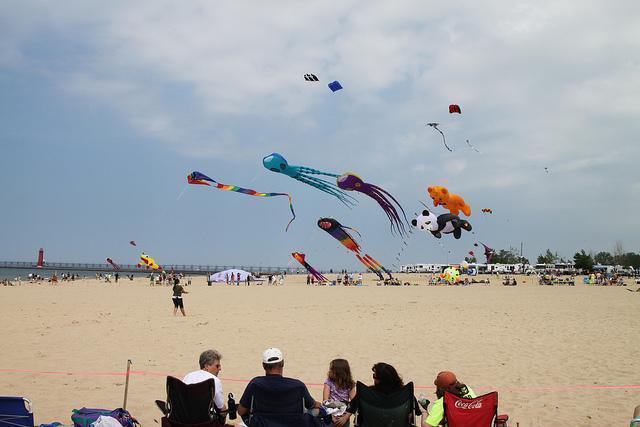How many yellow kites are in the air?
Give a very brief answer. 1. How many people are there?
Give a very brief answer. 2. 